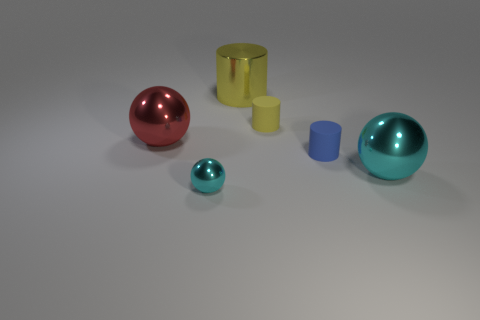Add 2 large yellow metal cylinders. How many objects exist? 8 Subtract all tiny cyan spheres. Subtract all small metal spheres. How many objects are left? 4 Add 4 blue matte objects. How many blue matte objects are left? 5 Add 5 small brown matte cylinders. How many small brown matte cylinders exist? 5 Subtract 1 blue cylinders. How many objects are left? 5 